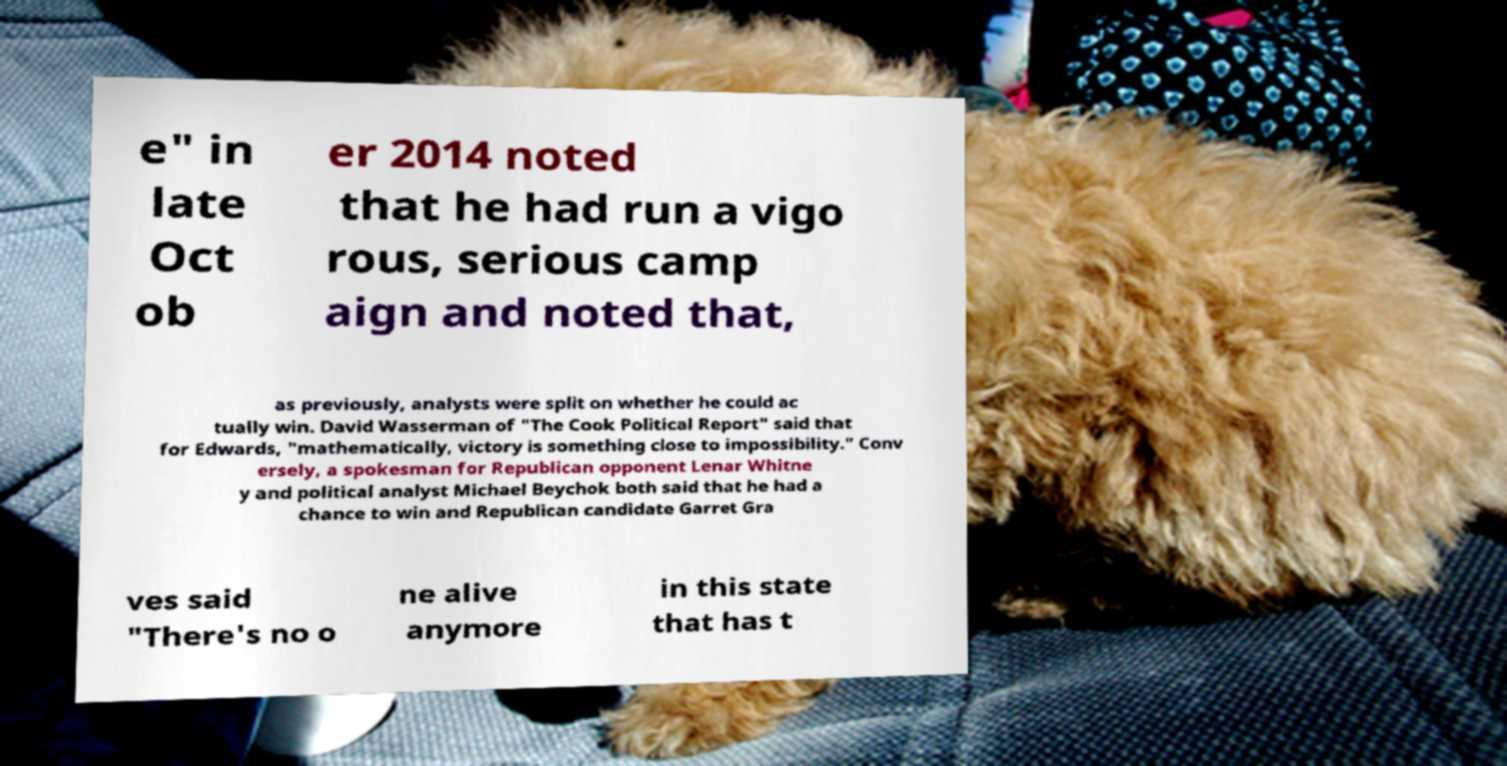There's text embedded in this image that I need extracted. Can you transcribe it verbatim? e" in late Oct ob er 2014 noted that he had run a vigo rous, serious camp aign and noted that, as previously, analysts were split on whether he could ac tually win. David Wasserman of "The Cook Political Report" said that for Edwards, "mathematically, victory is something close to impossibility." Conv ersely, a spokesman for Republican opponent Lenar Whitne y and political analyst Michael Beychok both said that he had a chance to win and Republican candidate Garret Gra ves said "There's no o ne alive anymore in this state that has t 